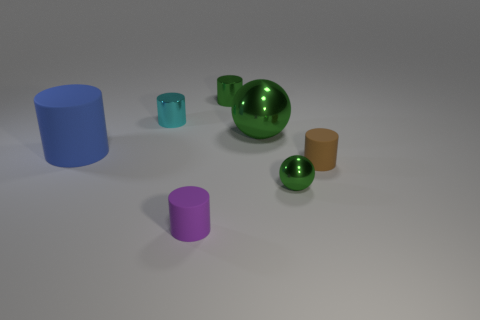Subtract all small brown cylinders. How many cylinders are left? 4 Subtract all cyan cylinders. How many cylinders are left? 4 Add 2 big brown metal balls. How many objects exist? 9 Subtract all yellow cylinders. Subtract all green blocks. How many cylinders are left? 5 Subtract all cylinders. How many objects are left? 2 Subtract 0 blue spheres. How many objects are left? 7 Subtract all tiny cyan things. Subtract all large cylinders. How many objects are left? 5 Add 4 brown matte cylinders. How many brown matte cylinders are left? 5 Add 7 brown things. How many brown things exist? 8 